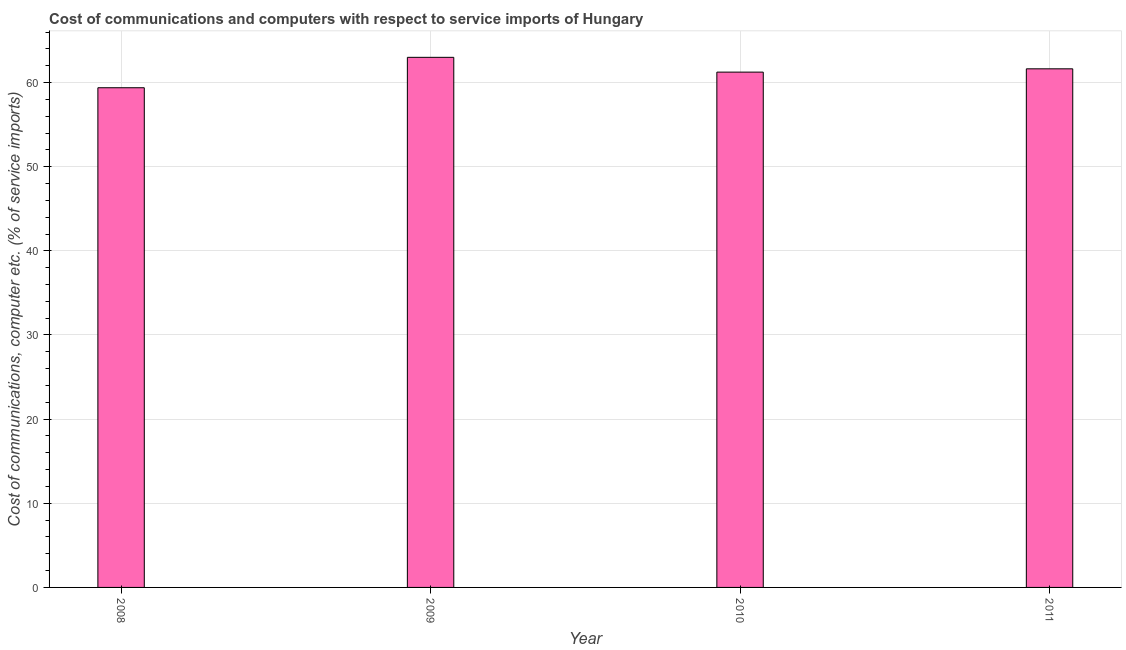Does the graph contain any zero values?
Offer a terse response. No. What is the title of the graph?
Make the answer very short. Cost of communications and computers with respect to service imports of Hungary. What is the label or title of the Y-axis?
Offer a very short reply. Cost of communications, computer etc. (% of service imports). What is the cost of communications and computer in 2011?
Your response must be concise. 61.63. Across all years, what is the maximum cost of communications and computer?
Offer a terse response. 63. Across all years, what is the minimum cost of communications and computer?
Your response must be concise. 59.38. In which year was the cost of communications and computer maximum?
Give a very brief answer. 2009. What is the sum of the cost of communications and computer?
Your answer should be compact. 245.25. What is the difference between the cost of communications and computer in 2009 and 2010?
Provide a short and direct response. 1.76. What is the average cost of communications and computer per year?
Keep it short and to the point. 61.31. What is the median cost of communications and computer?
Offer a terse response. 61.43. In how many years, is the cost of communications and computer greater than 46 %?
Provide a succinct answer. 4. What is the ratio of the cost of communications and computer in 2008 to that in 2009?
Your answer should be very brief. 0.94. Is the cost of communications and computer in 2010 less than that in 2011?
Give a very brief answer. Yes. Is the difference between the cost of communications and computer in 2009 and 2010 greater than the difference between any two years?
Provide a short and direct response. No. What is the difference between the highest and the second highest cost of communications and computer?
Your answer should be very brief. 1.37. Is the sum of the cost of communications and computer in 2009 and 2011 greater than the maximum cost of communications and computer across all years?
Keep it short and to the point. Yes. What is the difference between the highest and the lowest cost of communications and computer?
Offer a terse response. 3.61. How many bars are there?
Your answer should be compact. 4. How many years are there in the graph?
Provide a short and direct response. 4. What is the Cost of communications, computer etc. (% of service imports) of 2008?
Provide a succinct answer. 59.38. What is the Cost of communications, computer etc. (% of service imports) of 2009?
Your answer should be very brief. 63. What is the Cost of communications, computer etc. (% of service imports) in 2010?
Provide a succinct answer. 61.24. What is the Cost of communications, computer etc. (% of service imports) in 2011?
Your answer should be very brief. 61.63. What is the difference between the Cost of communications, computer etc. (% of service imports) in 2008 and 2009?
Provide a short and direct response. -3.61. What is the difference between the Cost of communications, computer etc. (% of service imports) in 2008 and 2010?
Your response must be concise. -1.86. What is the difference between the Cost of communications, computer etc. (% of service imports) in 2008 and 2011?
Give a very brief answer. -2.25. What is the difference between the Cost of communications, computer etc. (% of service imports) in 2009 and 2010?
Your answer should be very brief. 1.76. What is the difference between the Cost of communications, computer etc. (% of service imports) in 2009 and 2011?
Provide a short and direct response. 1.37. What is the difference between the Cost of communications, computer etc. (% of service imports) in 2010 and 2011?
Offer a very short reply. -0.39. What is the ratio of the Cost of communications, computer etc. (% of service imports) in 2008 to that in 2009?
Your answer should be very brief. 0.94. What is the ratio of the Cost of communications, computer etc. (% of service imports) in 2008 to that in 2010?
Your answer should be compact. 0.97. What is the ratio of the Cost of communications, computer etc. (% of service imports) in 2008 to that in 2011?
Offer a very short reply. 0.96. What is the ratio of the Cost of communications, computer etc. (% of service imports) in 2009 to that in 2010?
Offer a very short reply. 1.03. What is the ratio of the Cost of communications, computer etc. (% of service imports) in 2009 to that in 2011?
Provide a succinct answer. 1.02. 